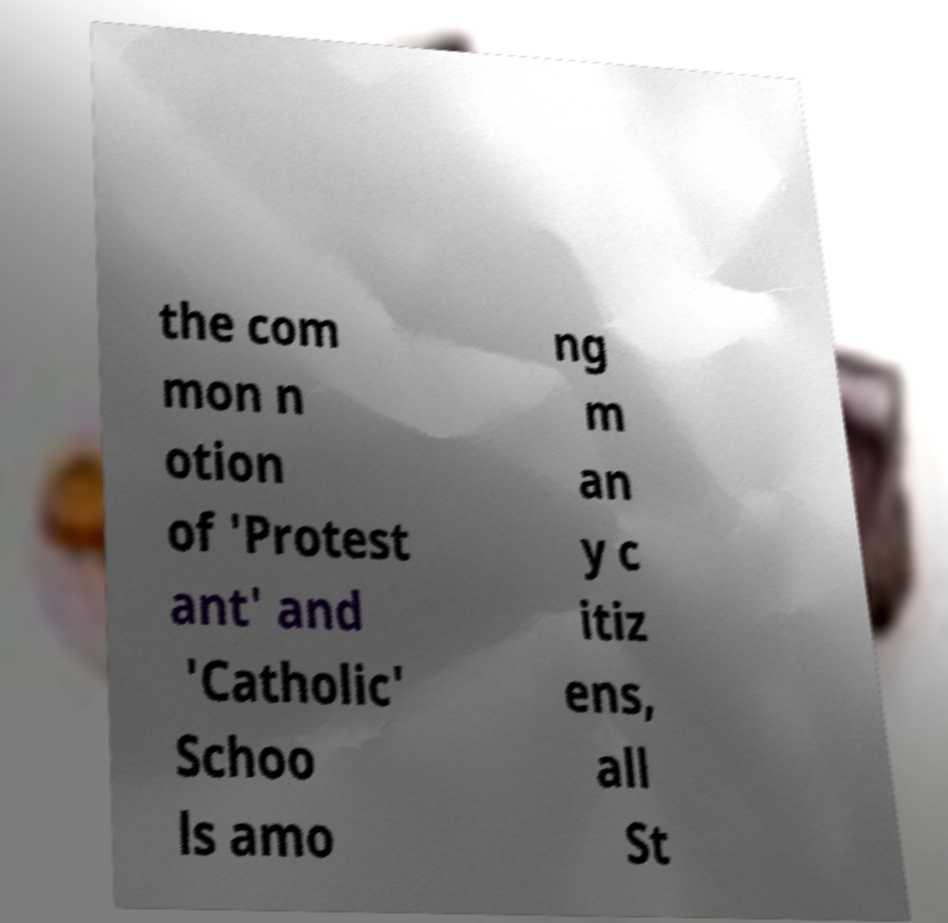What messages or text are displayed in this image? I need them in a readable, typed format. the com mon n otion of 'Protest ant' and 'Catholic' Schoo ls amo ng m an y c itiz ens, all St 